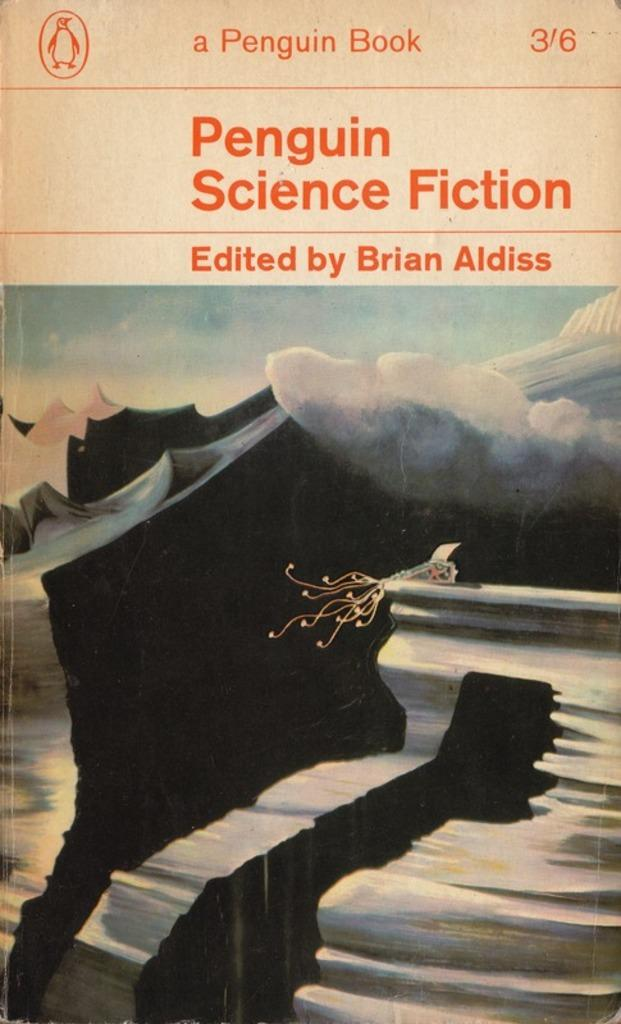What is the main subject of the image? The main subject of the image is a book cover. What can be seen on the book cover? There is text on the book cover. How many tickets are visible on the book cover in the image? There are no tickets visible on the book cover in the image. What type of transport is depicted on the book cover? There is no transport depicted on the book cover in the image. 